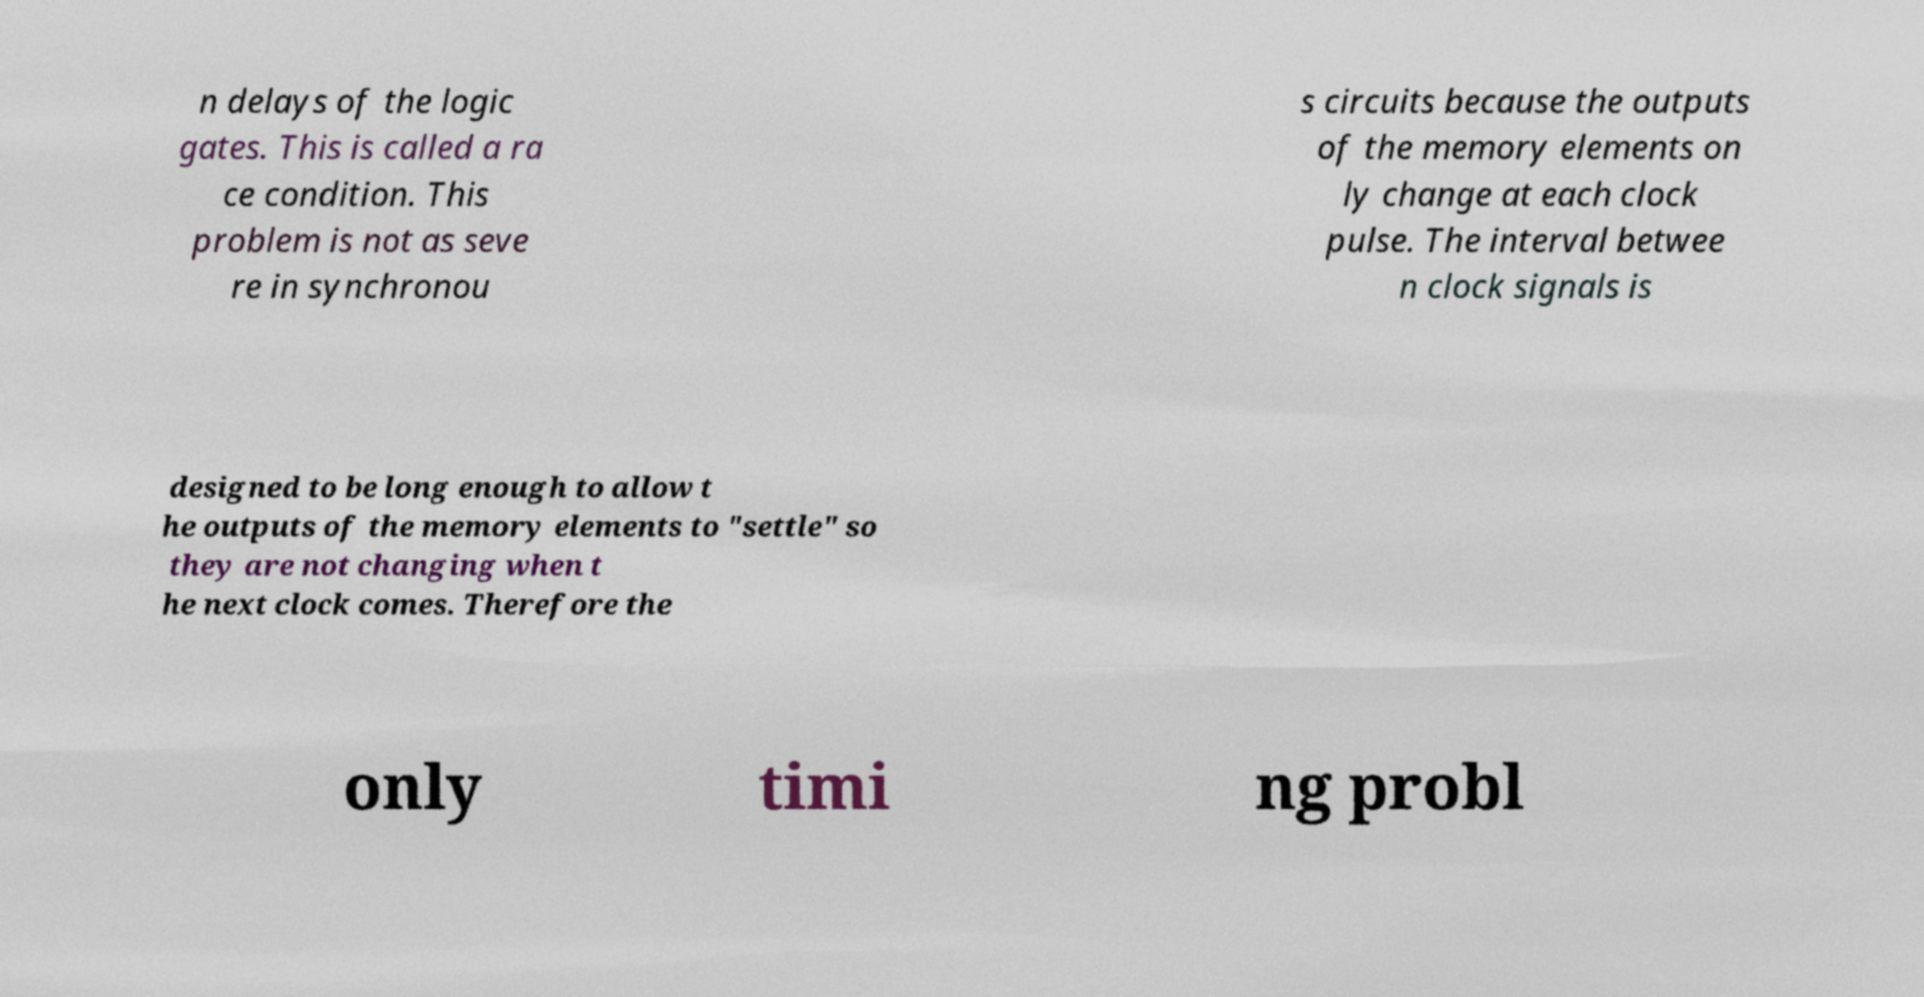Can you accurately transcribe the text from the provided image for me? n delays of the logic gates. This is called a ra ce condition. This problem is not as seve re in synchronou s circuits because the outputs of the memory elements on ly change at each clock pulse. The interval betwee n clock signals is designed to be long enough to allow t he outputs of the memory elements to "settle" so they are not changing when t he next clock comes. Therefore the only timi ng probl 